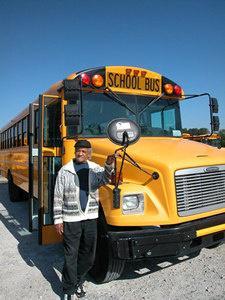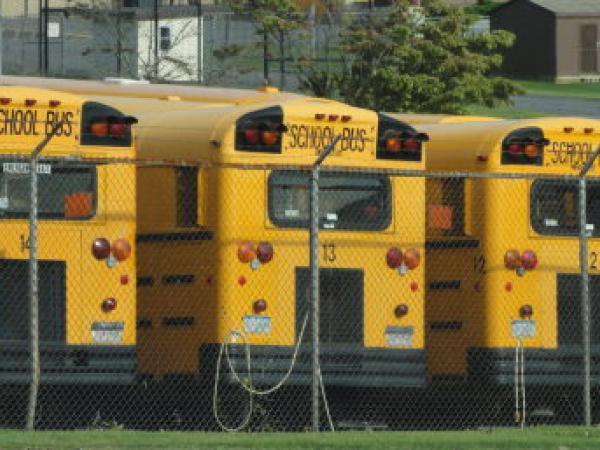The first image is the image on the left, the second image is the image on the right. Examine the images to the left and right. Is the description "In three of the images, the school bus is laying on it's side." accurate? Answer yes or no. No. The first image is the image on the left, the second image is the image on the right. Evaluate the accuracy of this statement regarding the images: "The right image contains a school bus that is flipped onto its side.". Is it true? Answer yes or no. No. 